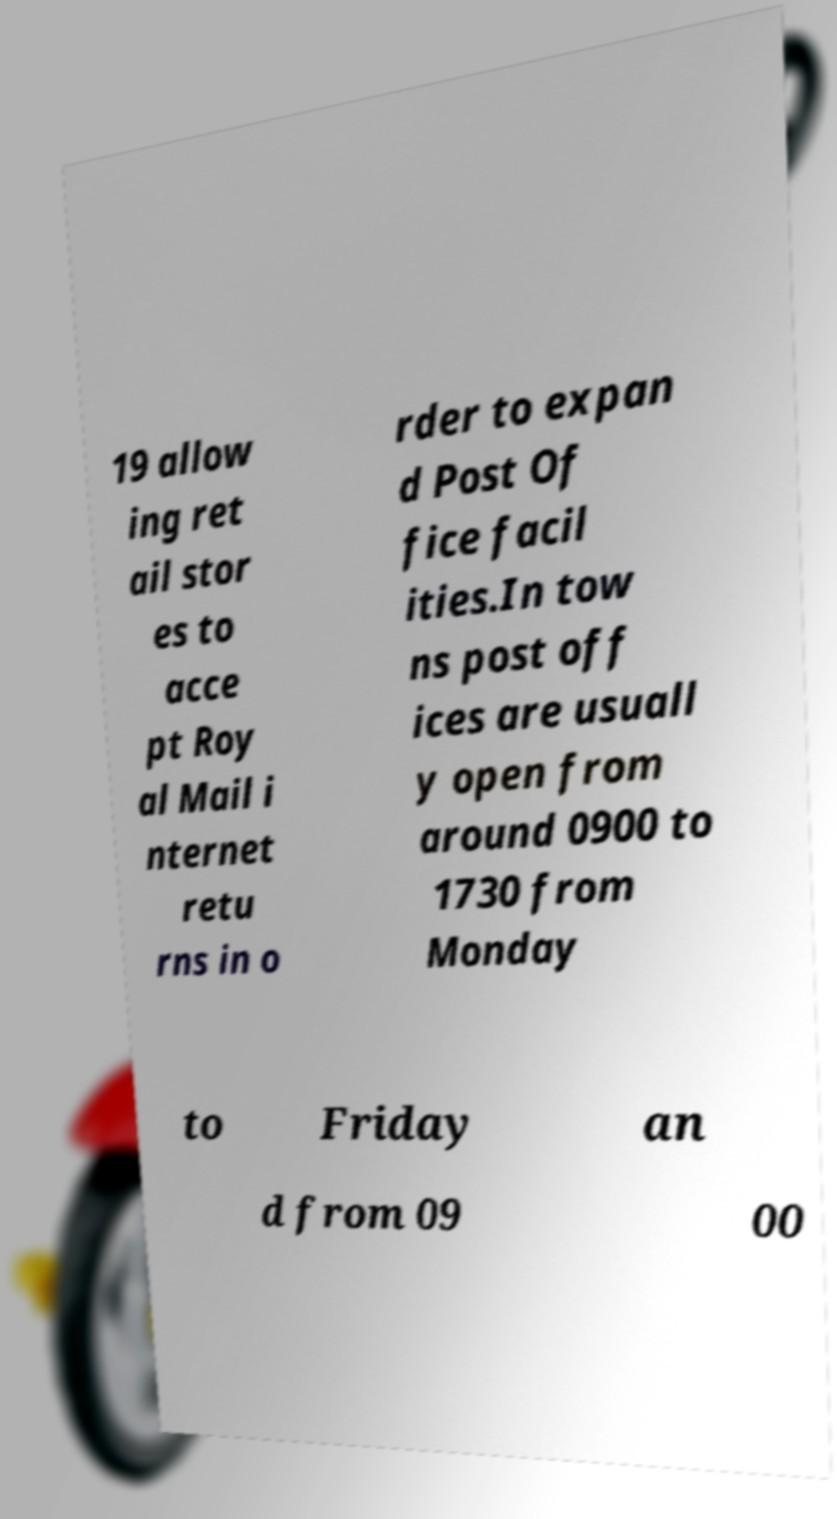For documentation purposes, I need the text within this image transcribed. Could you provide that? 19 allow ing ret ail stor es to acce pt Roy al Mail i nternet retu rns in o rder to expan d Post Of fice facil ities.In tow ns post off ices are usuall y open from around 0900 to 1730 from Monday to Friday an d from 09 00 